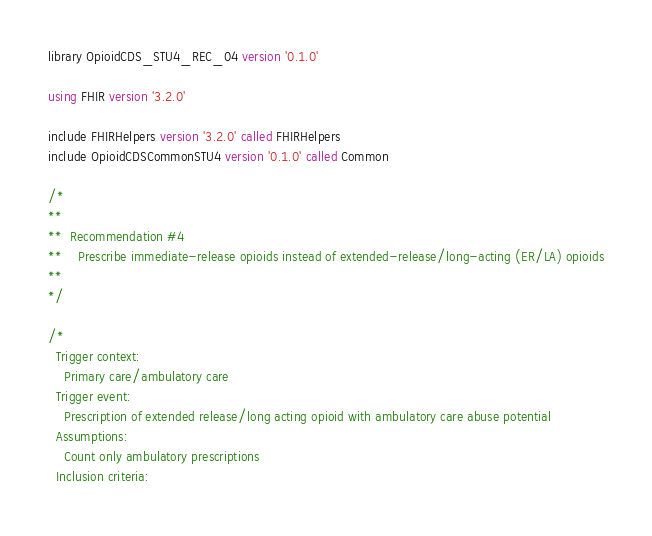Convert code to text. <code><loc_0><loc_0><loc_500><loc_500><_SQL_>library OpioidCDS_STU4_REC_04 version '0.1.0'

using FHIR version '3.2.0'

include FHIRHelpers version '3.2.0' called FHIRHelpers
include OpioidCDSCommonSTU4 version '0.1.0' called Common

/*
**
**  Recommendation #4
**    Prescribe immediate-release opioids instead of extended-release/long-acting (ER/LA) opioids
**
*/

/*
  Trigger context:
    Primary care/ambulatory care
  Trigger event:
    Prescription of extended release/long acting opioid with ambulatory care abuse potential
  Assumptions:
    Count only ambulatory prescriptions
  Inclusion criteria:</code> 